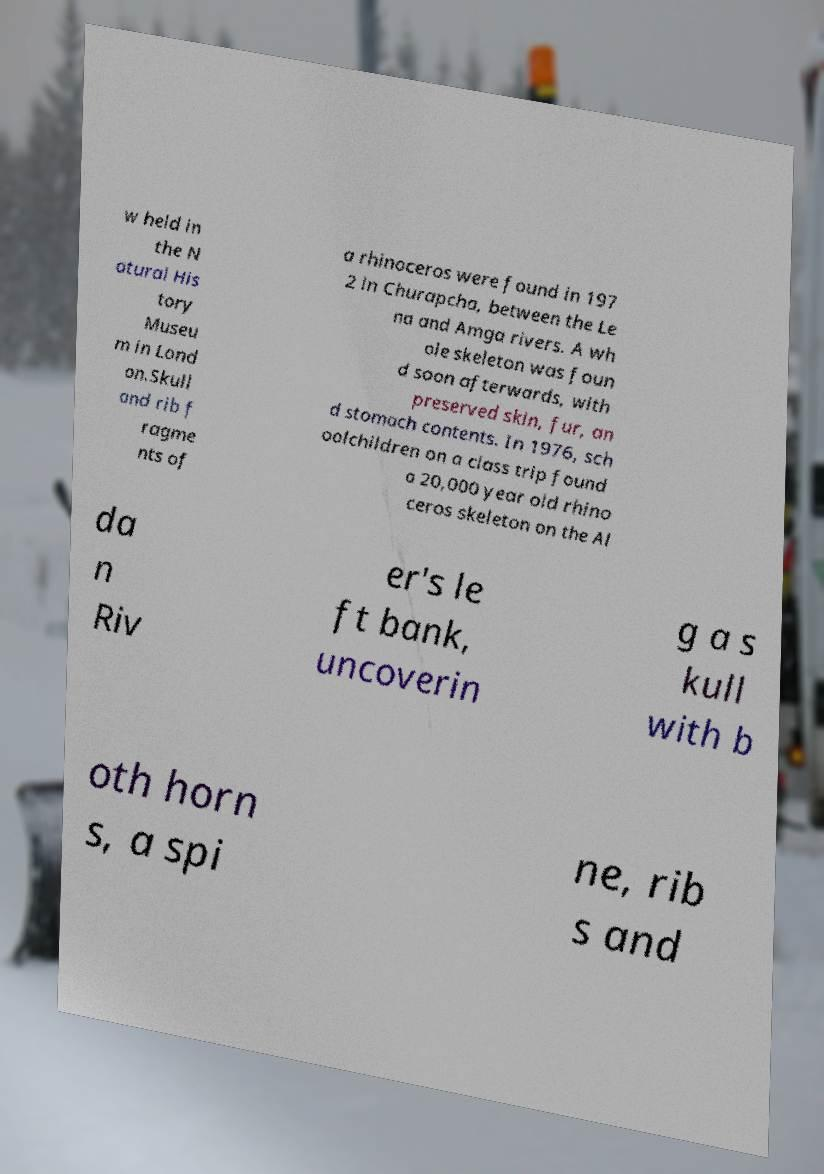Can you accurately transcribe the text from the provided image for me? w held in the N atural His tory Museu m in Lond on.Skull and rib f ragme nts of a rhinoceros were found in 197 2 in Churapcha, between the Le na and Amga rivers. A wh ole skeleton was foun d soon afterwards, with preserved skin, fur, an d stomach contents. In 1976, sch oolchildren on a class trip found a 20,000 year old rhino ceros skeleton on the Al da n Riv er's le ft bank, uncoverin g a s kull with b oth horn s, a spi ne, rib s and 